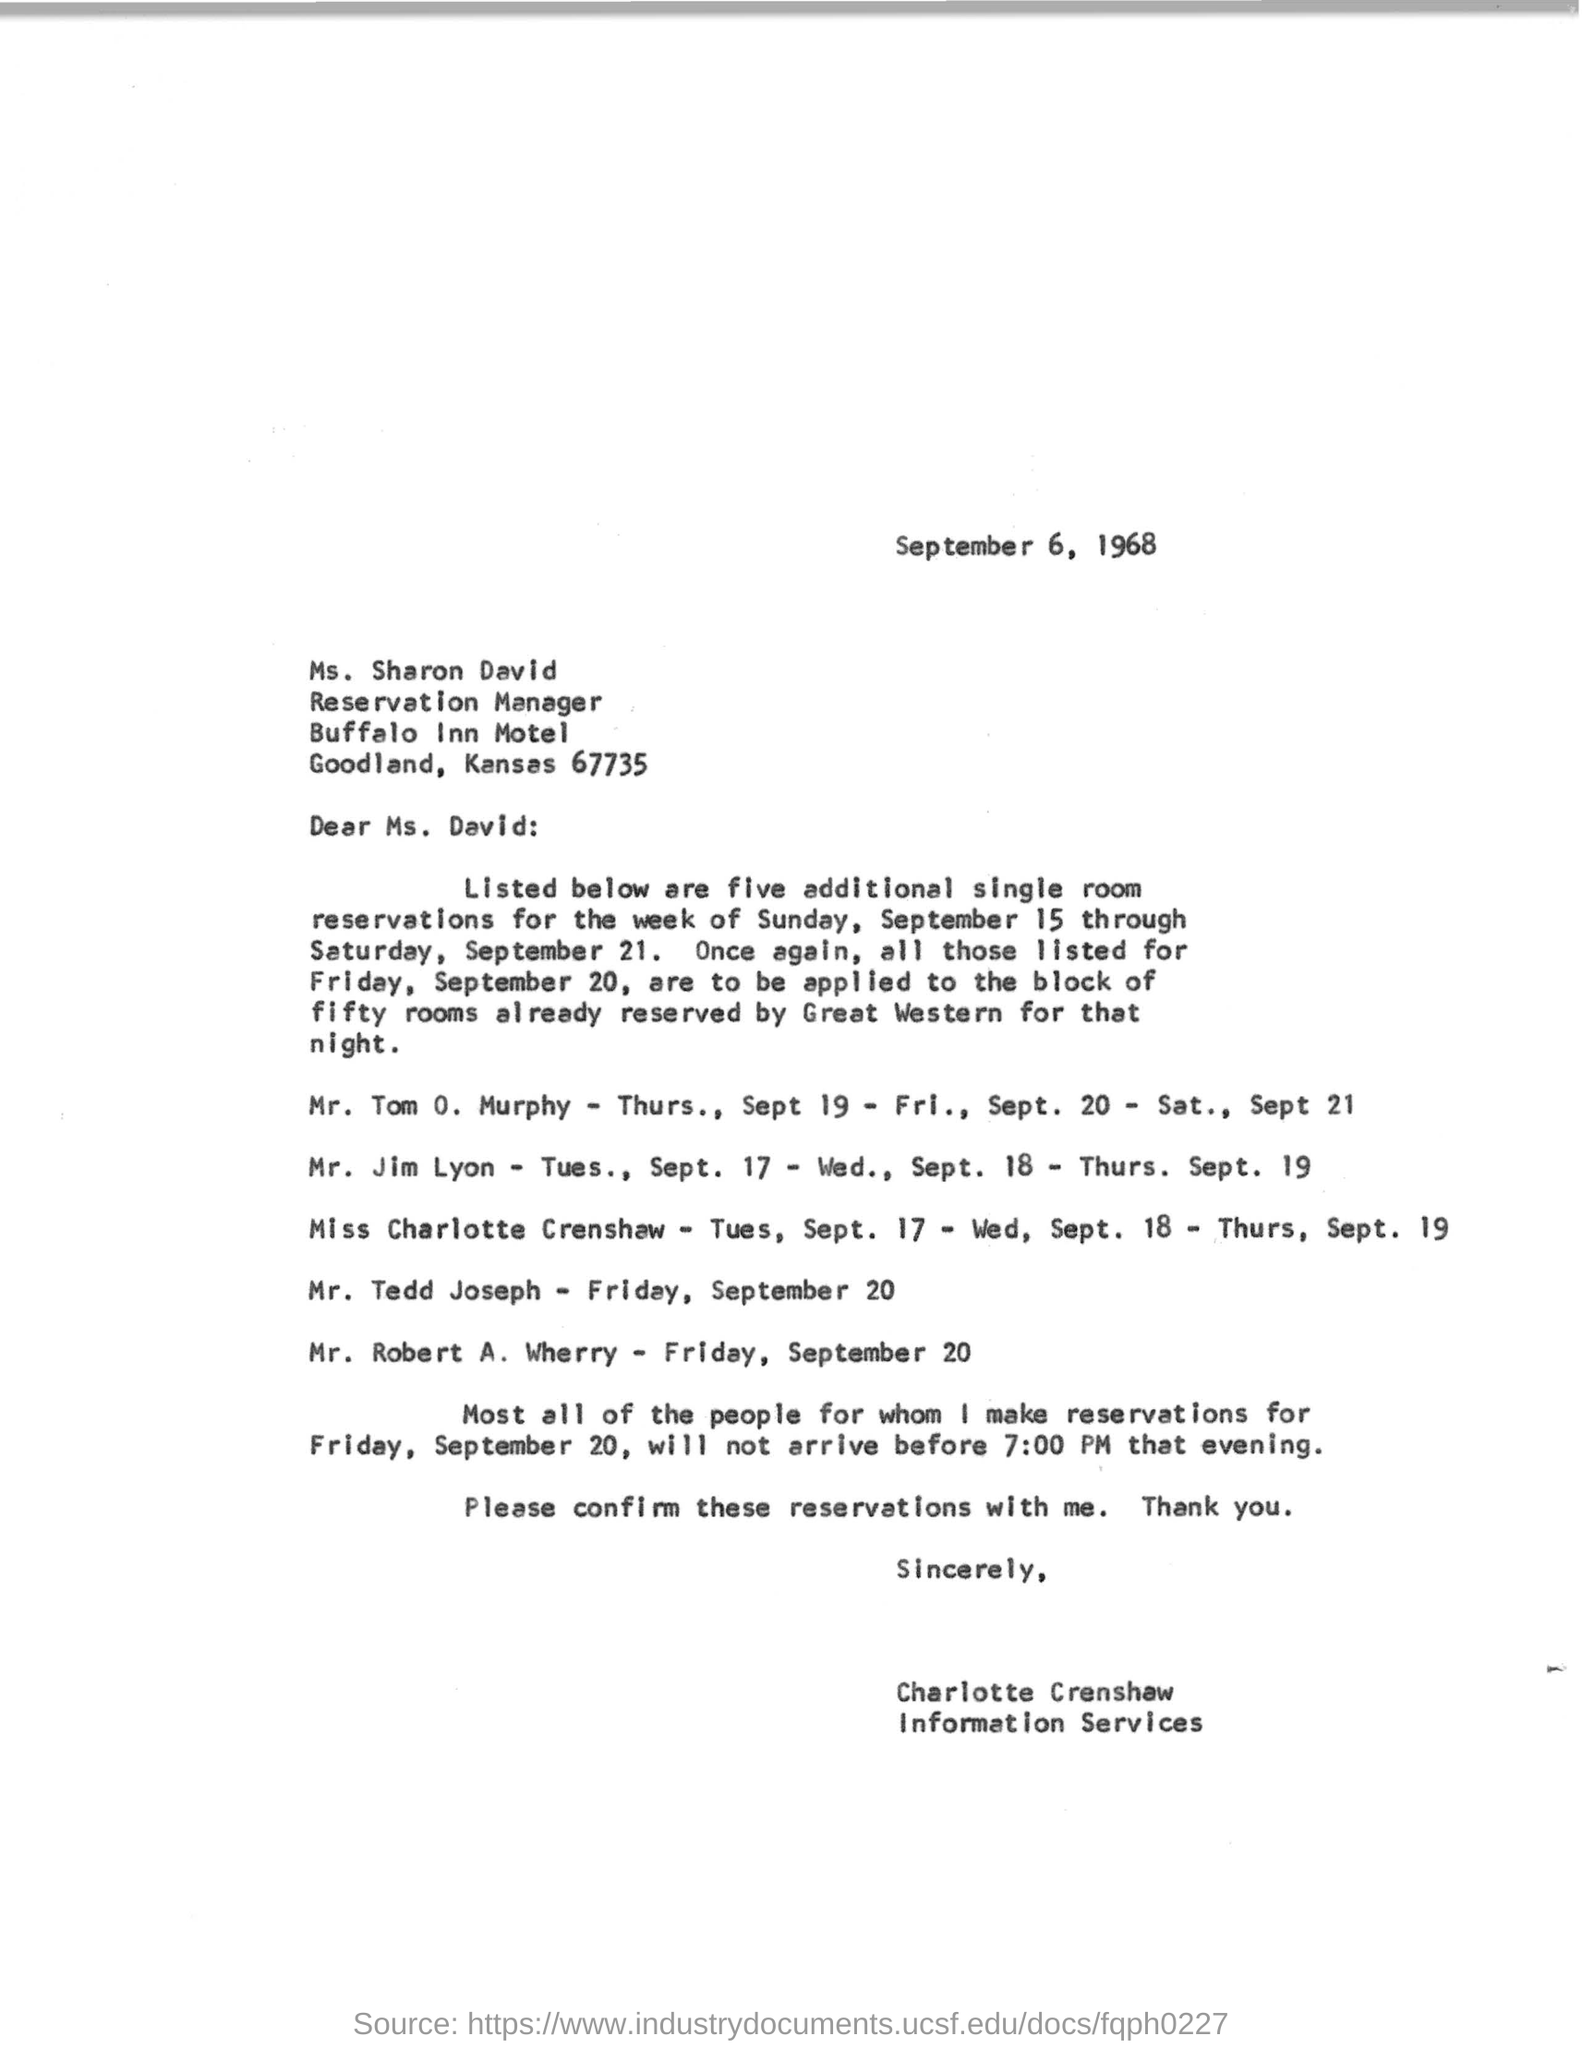Highlight a few significant elements in this photo. The Buffalo Inn Motel is located in Goodland, Kansas, at 67735. The reservation manager at the restaurant is named Ms. Sharon David. The letter is dated on September 6, 1968. It is on Friday, September 20th that a single room was reserved for Mr. Tedd Joseph. 